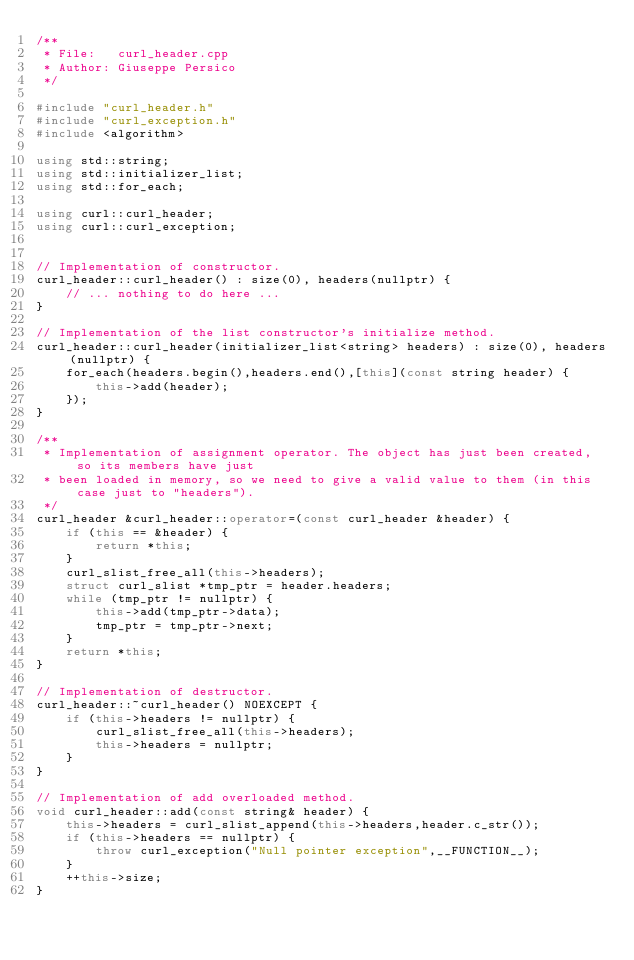<code> <loc_0><loc_0><loc_500><loc_500><_C++_>/**
 * File:   curl_header.cpp
 * Author: Giuseppe Persico
 */

#include "curl_header.h"
#include "curl_exception.h"
#include <algorithm>

using std::string;
using std::initializer_list;
using std::for_each;

using curl::curl_header;
using curl::curl_exception;


// Implementation of constructor.
curl_header::curl_header() : size(0), headers(nullptr) {
    // ... nothing to do here ...
}

// Implementation of the list constructor's initialize method.
curl_header::curl_header(initializer_list<string> headers) : size(0), headers(nullptr) {
    for_each(headers.begin(),headers.end(),[this](const string header) {
        this->add(header);
    });
}

/**
 * Implementation of assignment operator. The object has just been created, so its members have just
 * been loaded in memory, so we need to give a valid value to them (in this case just to "headers").
 */
curl_header &curl_header::operator=(const curl_header &header) {
    if (this == &header) {
        return *this;
    }
    curl_slist_free_all(this->headers);
    struct curl_slist *tmp_ptr = header.headers;
    while (tmp_ptr != nullptr) {
        this->add(tmp_ptr->data);
        tmp_ptr = tmp_ptr->next;
    }
    return *this;
}

// Implementation of destructor.
curl_header::~curl_header() NOEXCEPT {
    if (this->headers != nullptr) {
        curl_slist_free_all(this->headers);
        this->headers = nullptr;
    }
}

// Implementation of add overloaded method.
void curl_header::add(const string& header) {
    this->headers = curl_slist_append(this->headers,header.c_str());
    if (this->headers == nullptr) {
        throw curl_exception("Null pointer exception",__FUNCTION__);
    }
    ++this->size;
}
</code> 